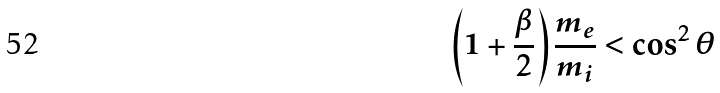<formula> <loc_0><loc_0><loc_500><loc_500>\left ( 1 + \frac { \beta } { 2 } \right ) \frac { m _ { e } } { m _ { i } } < \cos ^ { 2 } \theta</formula> 